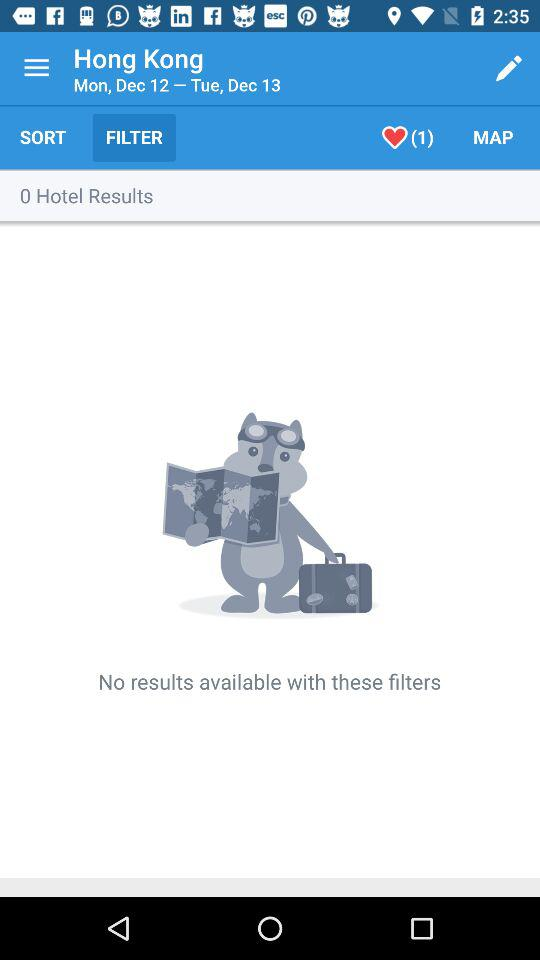How many days are in the date range?
Answer the question using a single word or phrase. 2 